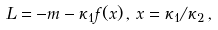<formula> <loc_0><loc_0><loc_500><loc_500>L = - m - \kappa _ { 1 } f ( x ) \, , \, x = \kappa _ { 1 } / \kappa _ { 2 } \, ,</formula> 